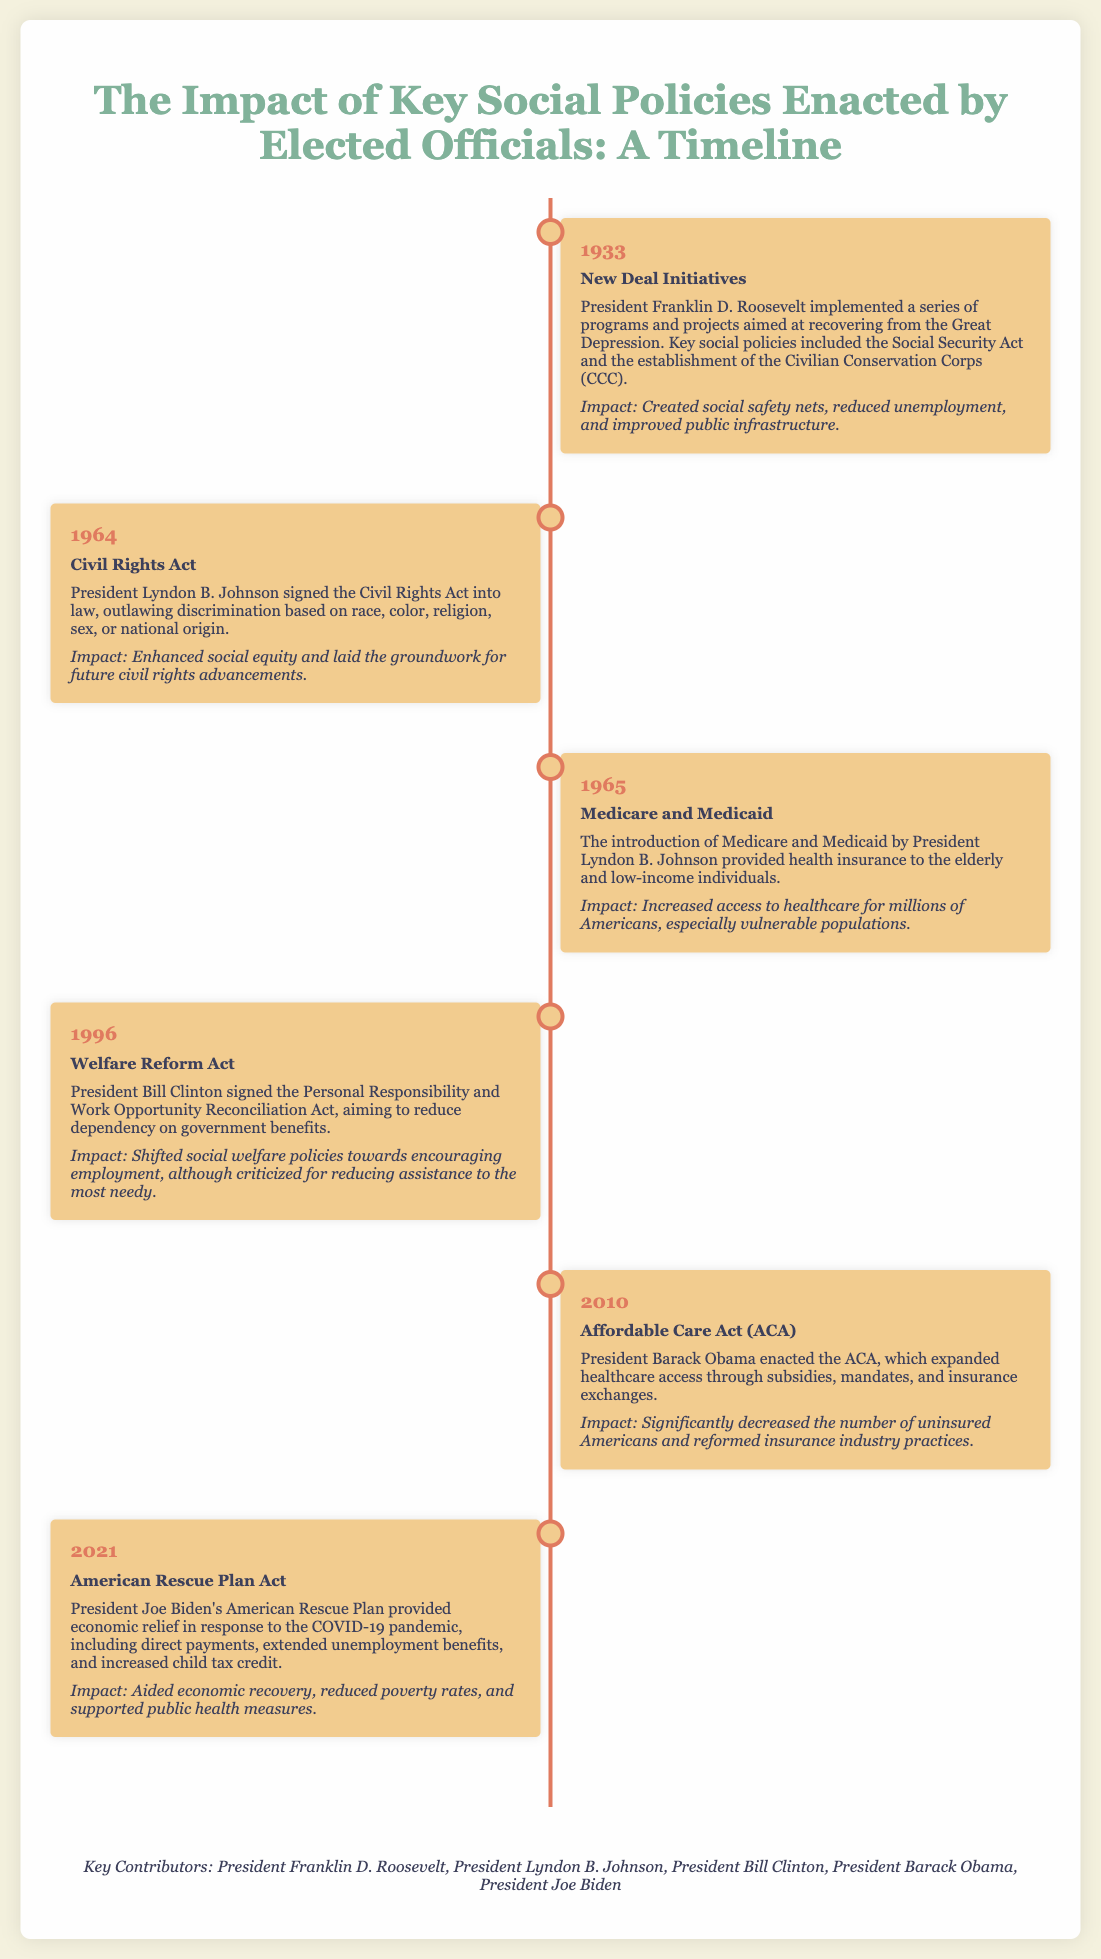What year was the New Deal Initiatives enacted? The New Deal Initiatives were implemented in the year mentioned in the timeline, which is 1933.
Answer: 1933 Who signed the Civil Rights Act into law? The document states that President Lyndon B. Johnson signed the Civil Rights Act into law in 1964.
Answer: Lyndon B. Johnson What was the main goal of the Welfare Reform Act of 1996? The Welfare Reform Act aimed to reduce dependency on government benefits, as indicated in the document.
Answer: Reduce dependency What significant healthcare legislation was enacted in 2010? The Affordable Care Act (ACA) is highlighted in the timeline as significant legislation enacted in that year.
Answer: Affordable Care Act What was a major impact of the American Rescue Plan Act? The Act aided economic recovery and reduced poverty rates, as described in the impact section of the timeline.
Answer: Reduced poverty rates Which president's initiatives aimed at recovering from the Great Depression? The document specifies that President Franklin D. Roosevelt implemented initiatives related to the Great Depression in 1933.
Answer: Franklin D. Roosevelt What health programs were introduced in 1965? Medicare and Medicaid were introduced in the year mentioned, which is 1965.
Answer: Medicare and Medicaid How many key contributors are mentioned in the document? The document lists five key contributors to the social policies outlined in the timeline.
Answer: Five What does the impact of the Affordable Care Act include? It includes significantly decreasing the number of uninsured Americans, as stated in the impact section.
Answer: Decreased uninsured Americans 